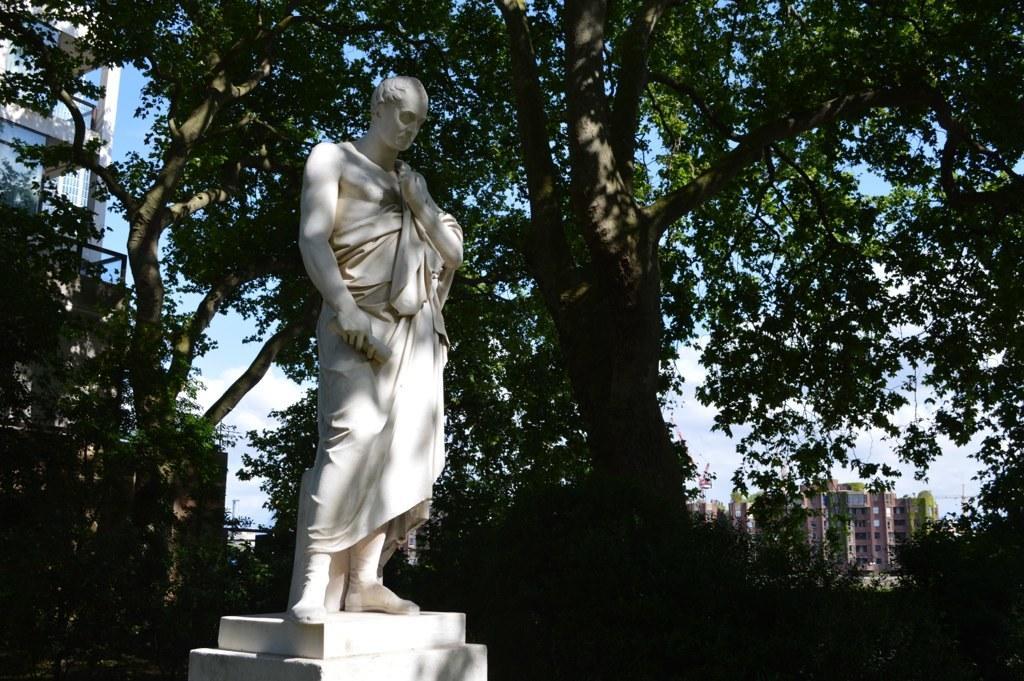Can you describe this image briefly? In the center of the image there is a statue. At the background of the image there are trees and there are buildings. 